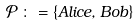<formula> <loc_0><loc_0><loc_500><loc_500>\mathcal { P } \, \colon = \{ A l i c e , B o b \}</formula> 